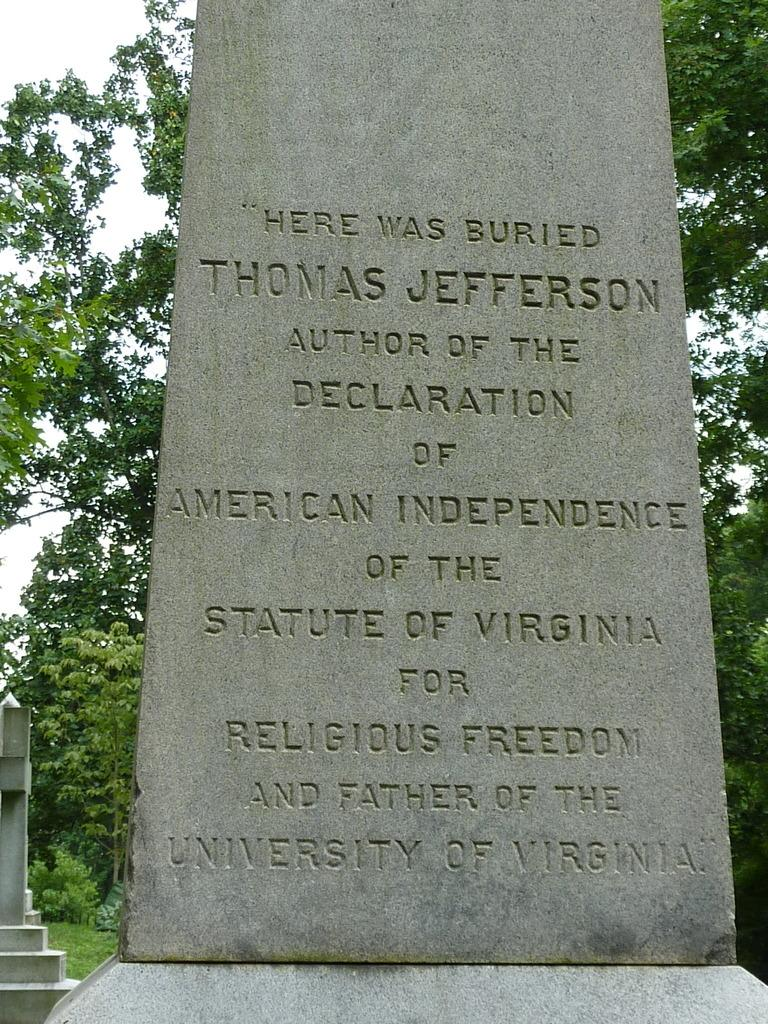What is written on in the image? There is writing on a stone in the image. What can be seen in the background of the image? There are trees, grass, and the sky visible in the background of the image. How many pairs of scissors are present in the image? There are no scissors present in the image. What type of ornament is hanging from the tree in the image? There is no ornament hanging from the tree in the image; only trees, grass, and the sky are visible in the background. 